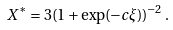Convert formula to latex. <formula><loc_0><loc_0><loc_500><loc_500>X ^ { * } = 3 ( 1 + \exp ( - c \xi ) ) ^ { - 2 } \, .</formula> 